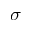<formula> <loc_0><loc_0><loc_500><loc_500>\sigma</formula> 